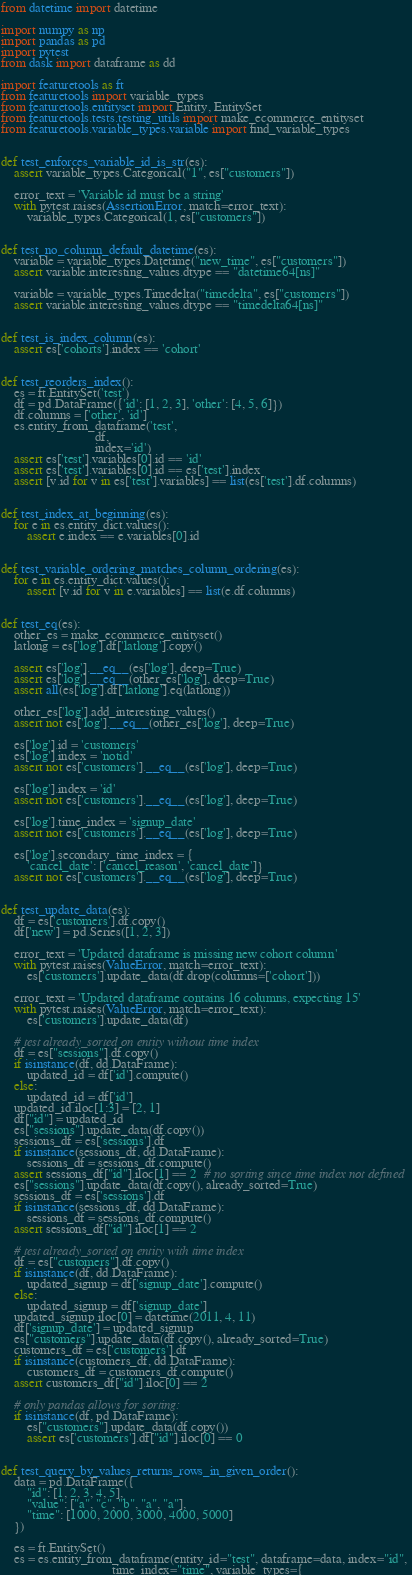Convert code to text. <code><loc_0><loc_0><loc_500><loc_500><_Python_>from datetime import datetime

import numpy as np
import pandas as pd
import pytest
from dask import dataframe as dd

import featuretools as ft
from featuretools import variable_types
from featuretools.entityset import Entity, EntitySet
from featuretools.tests.testing_utils import make_ecommerce_entityset
from featuretools.variable_types.variable import find_variable_types


def test_enforces_variable_id_is_str(es):
    assert variable_types.Categorical("1", es["customers"])

    error_text = 'Variable id must be a string'
    with pytest.raises(AssertionError, match=error_text):
        variable_types.Categorical(1, es["customers"])


def test_no_column_default_datetime(es):
    variable = variable_types.Datetime("new_time", es["customers"])
    assert variable.interesting_values.dtype == "datetime64[ns]"

    variable = variable_types.Timedelta("timedelta", es["customers"])
    assert variable.interesting_values.dtype == "timedelta64[ns]"


def test_is_index_column(es):
    assert es['cohorts'].index == 'cohort'


def test_reorders_index():
    es = ft.EntitySet('test')
    df = pd.DataFrame({'id': [1, 2, 3], 'other': [4, 5, 6]})
    df.columns = ['other', 'id']
    es.entity_from_dataframe('test',
                             df,
                             index='id')
    assert es['test'].variables[0].id == 'id'
    assert es['test'].variables[0].id == es['test'].index
    assert [v.id for v in es['test'].variables] == list(es['test'].df.columns)


def test_index_at_beginning(es):
    for e in es.entity_dict.values():
        assert e.index == e.variables[0].id


def test_variable_ordering_matches_column_ordering(es):
    for e in es.entity_dict.values():
        assert [v.id for v in e.variables] == list(e.df.columns)


def test_eq(es):
    other_es = make_ecommerce_entityset()
    latlong = es['log'].df['latlong'].copy()

    assert es['log'].__eq__(es['log'], deep=True)
    assert es['log'].__eq__(other_es['log'], deep=True)
    assert all(es['log'].df['latlong'].eq(latlong))

    other_es['log'].add_interesting_values()
    assert not es['log'].__eq__(other_es['log'], deep=True)

    es['log'].id = 'customers'
    es['log'].index = 'notid'
    assert not es['customers'].__eq__(es['log'], deep=True)

    es['log'].index = 'id'
    assert not es['customers'].__eq__(es['log'], deep=True)

    es['log'].time_index = 'signup_date'
    assert not es['customers'].__eq__(es['log'], deep=True)

    es['log'].secondary_time_index = {
        'cancel_date': ['cancel_reason', 'cancel_date']}
    assert not es['customers'].__eq__(es['log'], deep=True)


def test_update_data(es):
    df = es['customers'].df.copy()
    df['new'] = pd.Series([1, 2, 3])

    error_text = 'Updated dataframe is missing new cohort column'
    with pytest.raises(ValueError, match=error_text):
        es['customers'].update_data(df.drop(columns=['cohort']))

    error_text = 'Updated dataframe contains 16 columns, expecting 15'
    with pytest.raises(ValueError, match=error_text):
        es['customers'].update_data(df)

    # test already_sorted on entity without time index
    df = es["sessions"].df.copy()
    if isinstance(df, dd.DataFrame):
        updated_id = df['id'].compute()
    else:
        updated_id = df['id']
    updated_id.iloc[1:3] = [2, 1]
    df["id"] = updated_id
    es["sessions"].update_data(df.copy())
    sessions_df = es['sessions'].df
    if isinstance(sessions_df, dd.DataFrame):
        sessions_df = sessions_df.compute()
    assert sessions_df["id"].iloc[1] == 2  # no sorting since time index not defined
    es["sessions"].update_data(df.copy(), already_sorted=True)
    sessions_df = es['sessions'].df
    if isinstance(sessions_df, dd.DataFrame):
        sessions_df = sessions_df.compute()
    assert sessions_df["id"].iloc[1] == 2

    # test already_sorted on entity with time index
    df = es["customers"].df.copy()
    if isinstance(df, dd.DataFrame):
        updated_signup = df['signup_date'].compute()
    else:
        updated_signup = df['signup_date']
    updated_signup.iloc[0] = datetime(2011, 4, 11)
    df['signup_date'] = updated_signup
    es["customers"].update_data(df.copy(), already_sorted=True)
    customers_df = es['customers'].df
    if isinstance(customers_df, dd.DataFrame):
        customers_df = customers_df.compute()
    assert customers_df["id"].iloc[0] == 2

    # only pandas allows for sorting:
    if isinstance(df, pd.DataFrame):
        es["customers"].update_data(df.copy())
        assert es['customers'].df["id"].iloc[0] == 0


def test_query_by_values_returns_rows_in_given_order():
    data = pd.DataFrame({
        "id": [1, 2, 3, 4, 5],
        "value": ["a", "c", "b", "a", "a"],
        "time": [1000, 2000, 3000, 4000, 5000]
    })

    es = ft.EntitySet()
    es = es.entity_from_dataframe(entity_id="test", dataframe=data, index="id",
                                  time_index="time", variable_types={</code> 